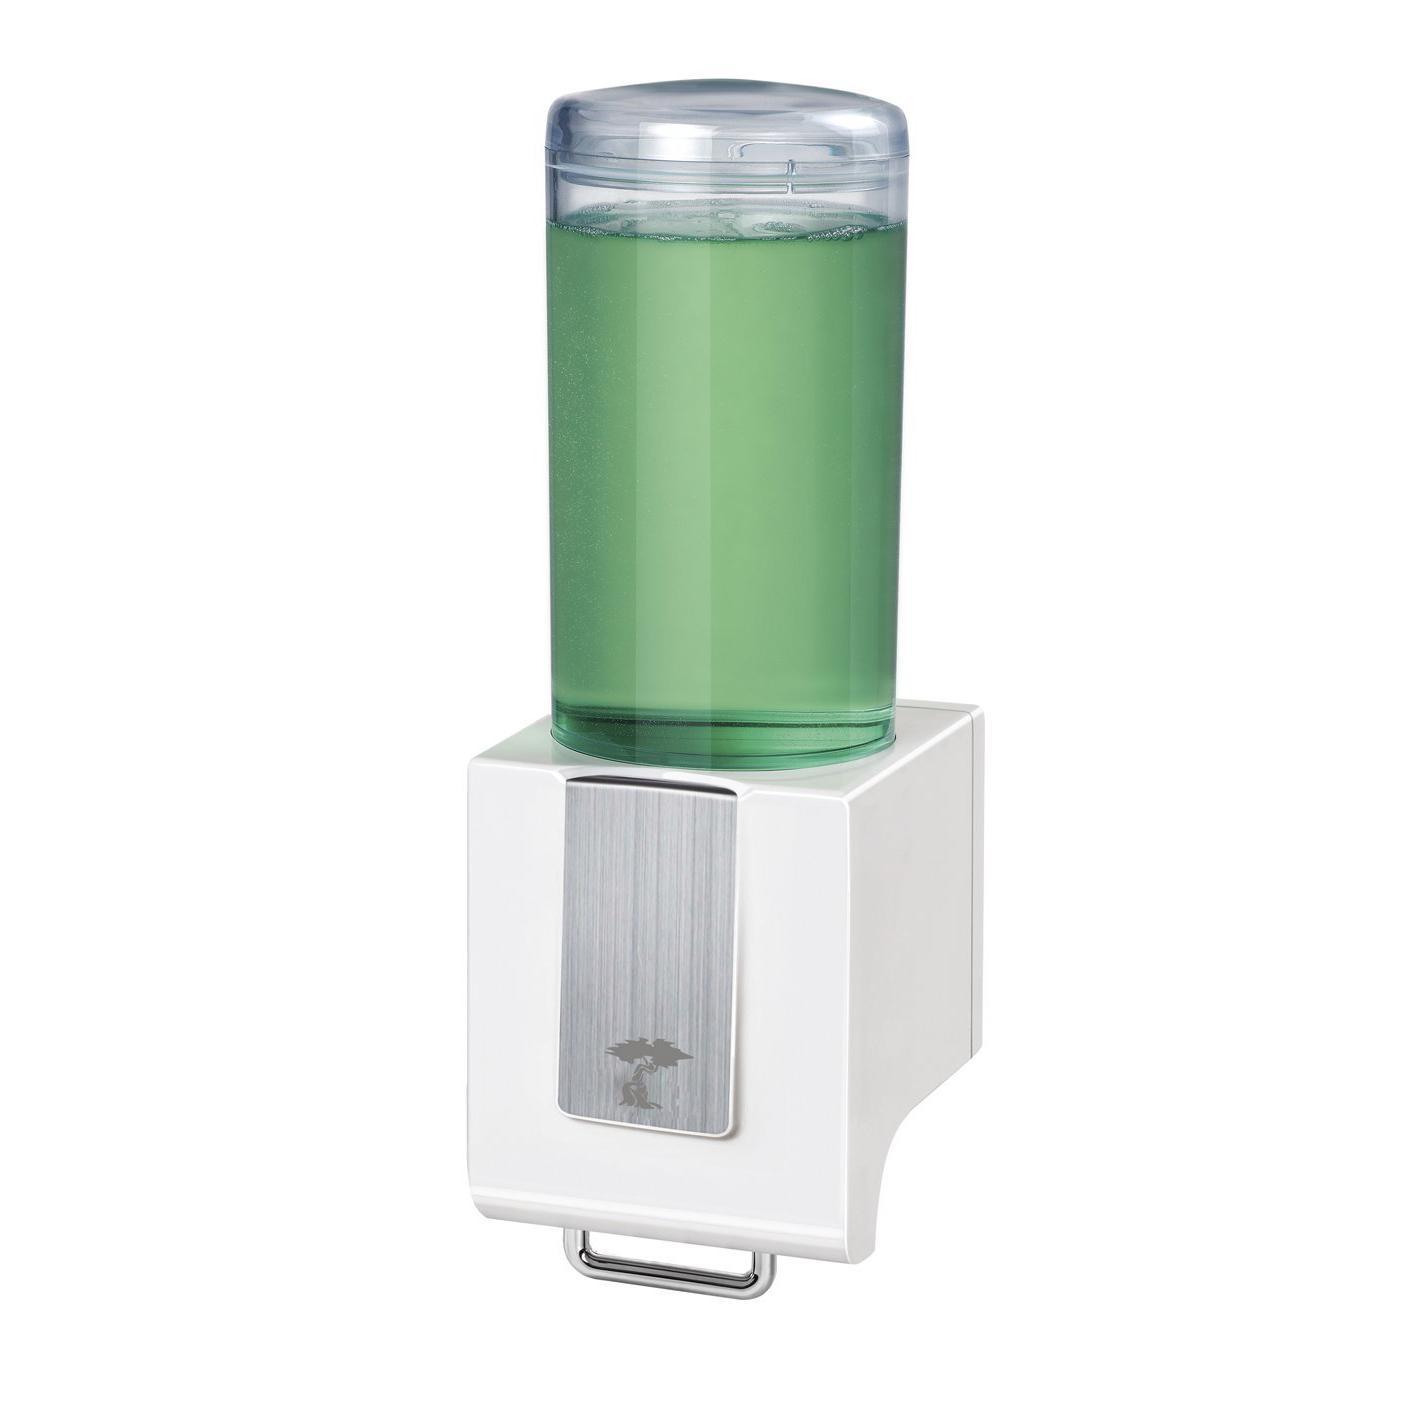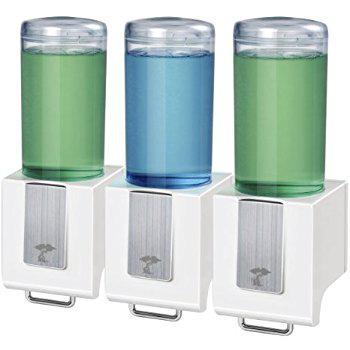The first image is the image on the left, the second image is the image on the right. For the images displayed, is the sentence "Each image shows three side-by-side dispensers, with at least one containing a bluish substance." factually correct? Answer yes or no. No. The first image is the image on the left, the second image is the image on the right. Assess this claim about the two images: "There are three dispensers filled with substances in each of the images.". Correct or not? Answer yes or no. No. 